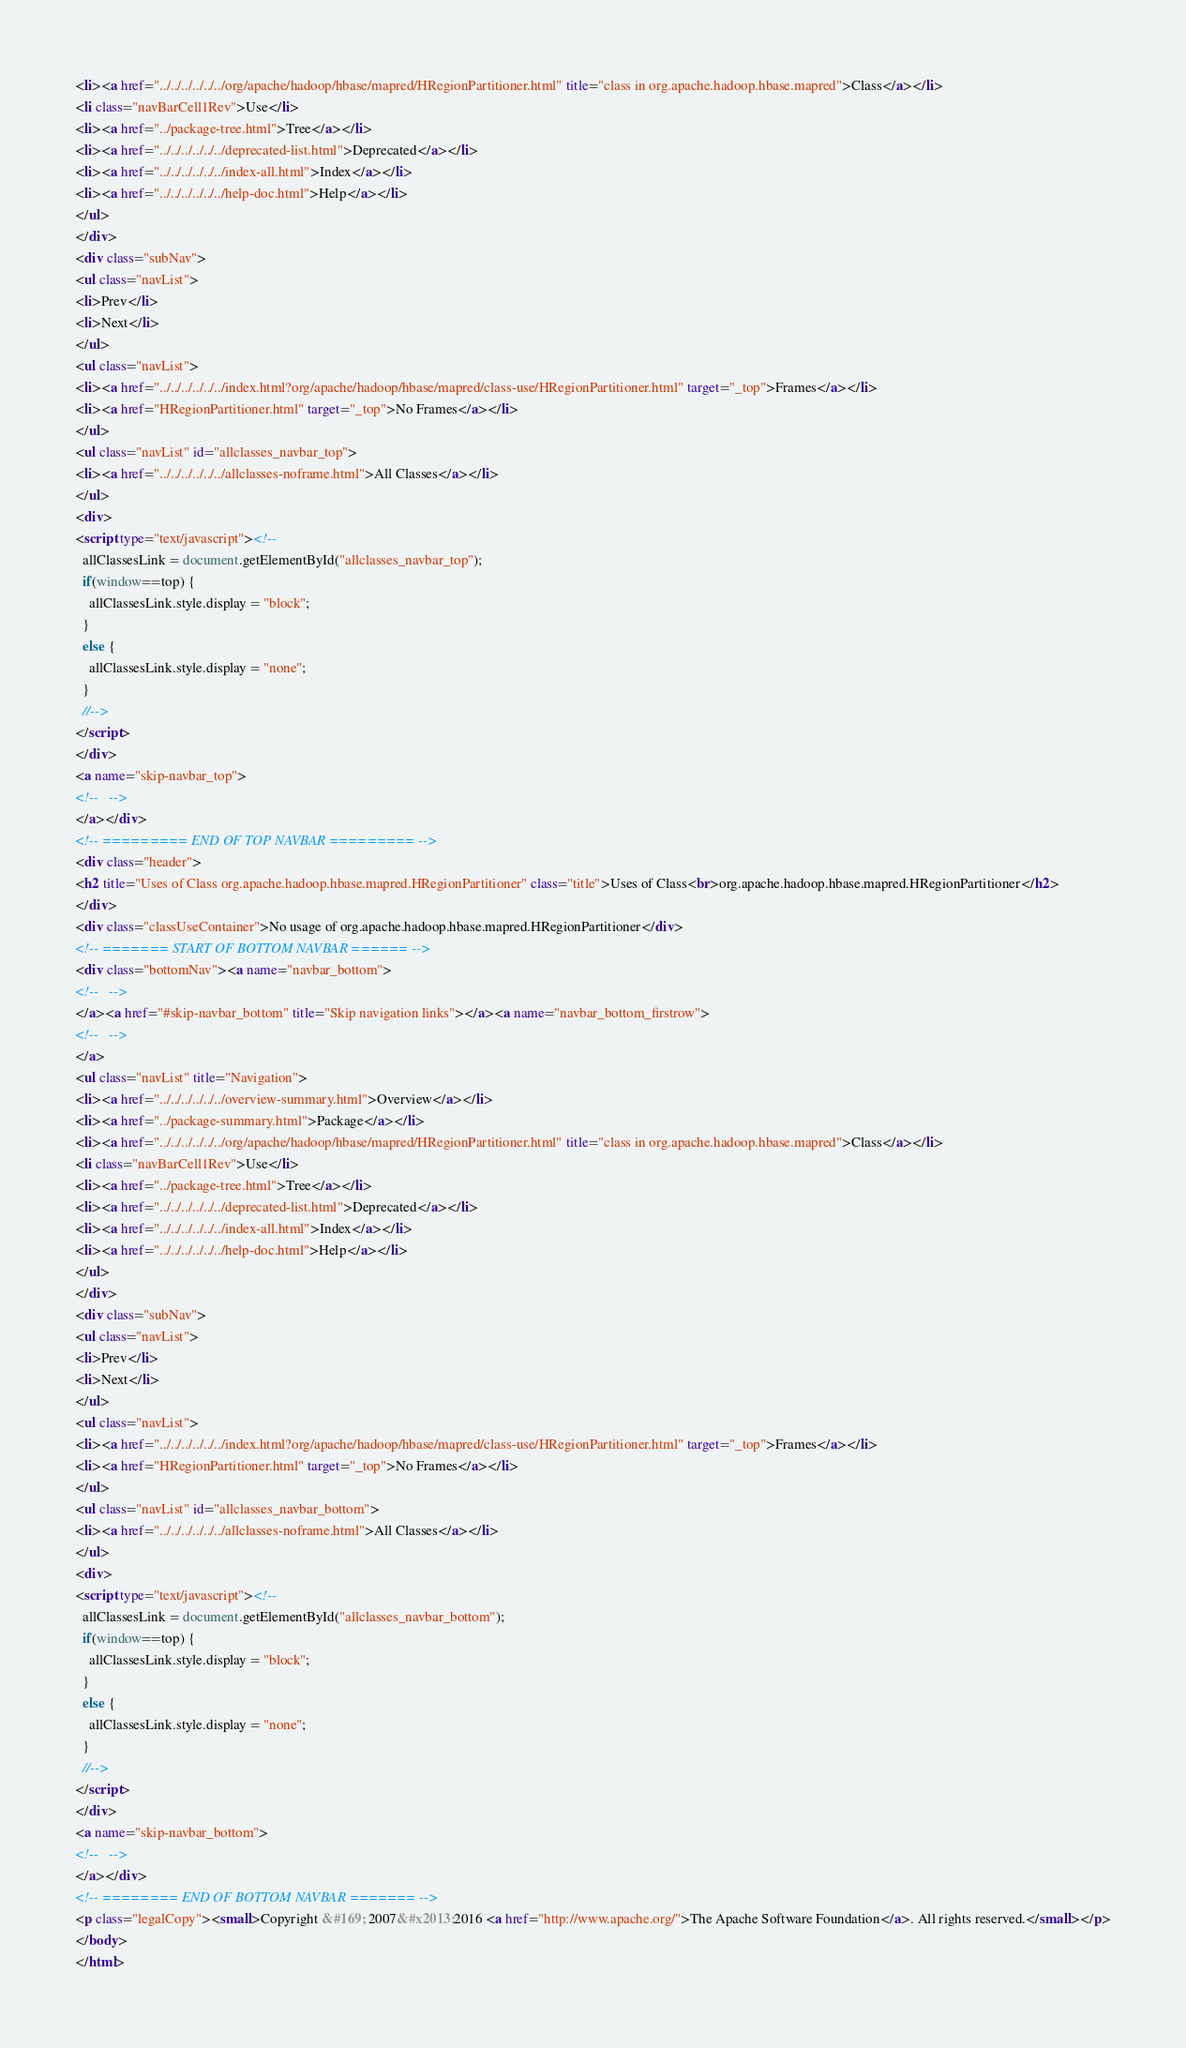Convert code to text. <code><loc_0><loc_0><loc_500><loc_500><_HTML_><li><a href="../../../../../../org/apache/hadoop/hbase/mapred/HRegionPartitioner.html" title="class in org.apache.hadoop.hbase.mapred">Class</a></li>
<li class="navBarCell1Rev">Use</li>
<li><a href="../package-tree.html">Tree</a></li>
<li><a href="../../../../../../deprecated-list.html">Deprecated</a></li>
<li><a href="../../../../../../index-all.html">Index</a></li>
<li><a href="../../../../../../help-doc.html">Help</a></li>
</ul>
</div>
<div class="subNav">
<ul class="navList">
<li>Prev</li>
<li>Next</li>
</ul>
<ul class="navList">
<li><a href="../../../../../../index.html?org/apache/hadoop/hbase/mapred/class-use/HRegionPartitioner.html" target="_top">Frames</a></li>
<li><a href="HRegionPartitioner.html" target="_top">No Frames</a></li>
</ul>
<ul class="navList" id="allclasses_navbar_top">
<li><a href="../../../../../../allclasses-noframe.html">All Classes</a></li>
</ul>
<div>
<script type="text/javascript"><!--
  allClassesLink = document.getElementById("allclasses_navbar_top");
  if(window==top) {
    allClassesLink.style.display = "block";
  }
  else {
    allClassesLink.style.display = "none";
  }
  //-->
</script>
</div>
<a name="skip-navbar_top">
<!--   -->
</a></div>
<!-- ========= END OF TOP NAVBAR ========= -->
<div class="header">
<h2 title="Uses of Class org.apache.hadoop.hbase.mapred.HRegionPartitioner" class="title">Uses of Class<br>org.apache.hadoop.hbase.mapred.HRegionPartitioner</h2>
</div>
<div class="classUseContainer">No usage of org.apache.hadoop.hbase.mapred.HRegionPartitioner</div>
<!-- ======= START OF BOTTOM NAVBAR ====== -->
<div class="bottomNav"><a name="navbar_bottom">
<!--   -->
</a><a href="#skip-navbar_bottom" title="Skip navigation links"></a><a name="navbar_bottom_firstrow">
<!--   -->
</a>
<ul class="navList" title="Navigation">
<li><a href="../../../../../../overview-summary.html">Overview</a></li>
<li><a href="../package-summary.html">Package</a></li>
<li><a href="../../../../../../org/apache/hadoop/hbase/mapred/HRegionPartitioner.html" title="class in org.apache.hadoop.hbase.mapred">Class</a></li>
<li class="navBarCell1Rev">Use</li>
<li><a href="../package-tree.html">Tree</a></li>
<li><a href="../../../../../../deprecated-list.html">Deprecated</a></li>
<li><a href="../../../../../../index-all.html">Index</a></li>
<li><a href="../../../../../../help-doc.html">Help</a></li>
</ul>
</div>
<div class="subNav">
<ul class="navList">
<li>Prev</li>
<li>Next</li>
</ul>
<ul class="navList">
<li><a href="../../../../../../index.html?org/apache/hadoop/hbase/mapred/class-use/HRegionPartitioner.html" target="_top">Frames</a></li>
<li><a href="HRegionPartitioner.html" target="_top">No Frames</a></li>
</ul>
<ul class="navList" id="allclasses_navbar_bottom">
<li><a href="../../../../../../allclasses-noframe.html">All Classes</a></li>
</ul>
<div>
<script type="text/javascript"><!--
  allClassesLink = document.getElementById("allclasses_navbar_bottom");
  if(window==top) {
    allClassesLink.style.display = "block";
  }
  else {
    allClassesLink.style.display = "none";
  }
  //-->
</script>
</div>
<a name="skip-navbar_bottom">
<!--   -->
</a></div>
<!-- ======== END OF BOTTOM NAVBAR ======= -->
<p class="legalCopy"><small>Copyright &#169; 2007&#x2013;2016 <a href="http://www.apache.org/">The Apache Software Foundation</a>. All rights reserved.</small></p>
</body>
</html>
</code> 